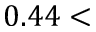<formula> <loc_0><loc_0><loc_500><loc_500>0 . 4 4 <</formula> 